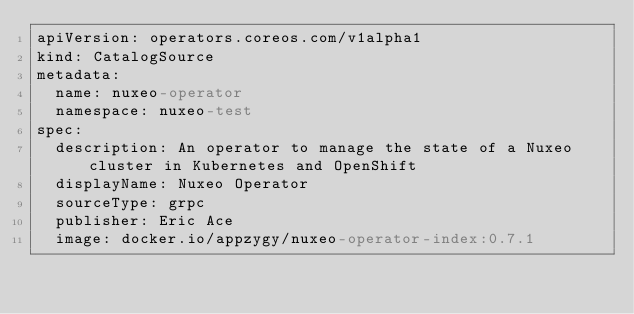<code> <loc_0><loc_0><loc_500><loc_500><_YAML_>apiVersion: operators.coreos.com/v1alpha1
kind: CatalogSource
metadata:
  name: nuxeo-operator
  namespace: nuxeo-test
spec:
  description: An operator to manage the state of a Nuxeo cluster in Kubernetes and OpenShift
  displayName: Nuxeo Operator
  sourceType: grpc
  publisher: Eric Ace
  image: docker.io/appzygy/nuxeo-operator-index:0.7.1
</code> 